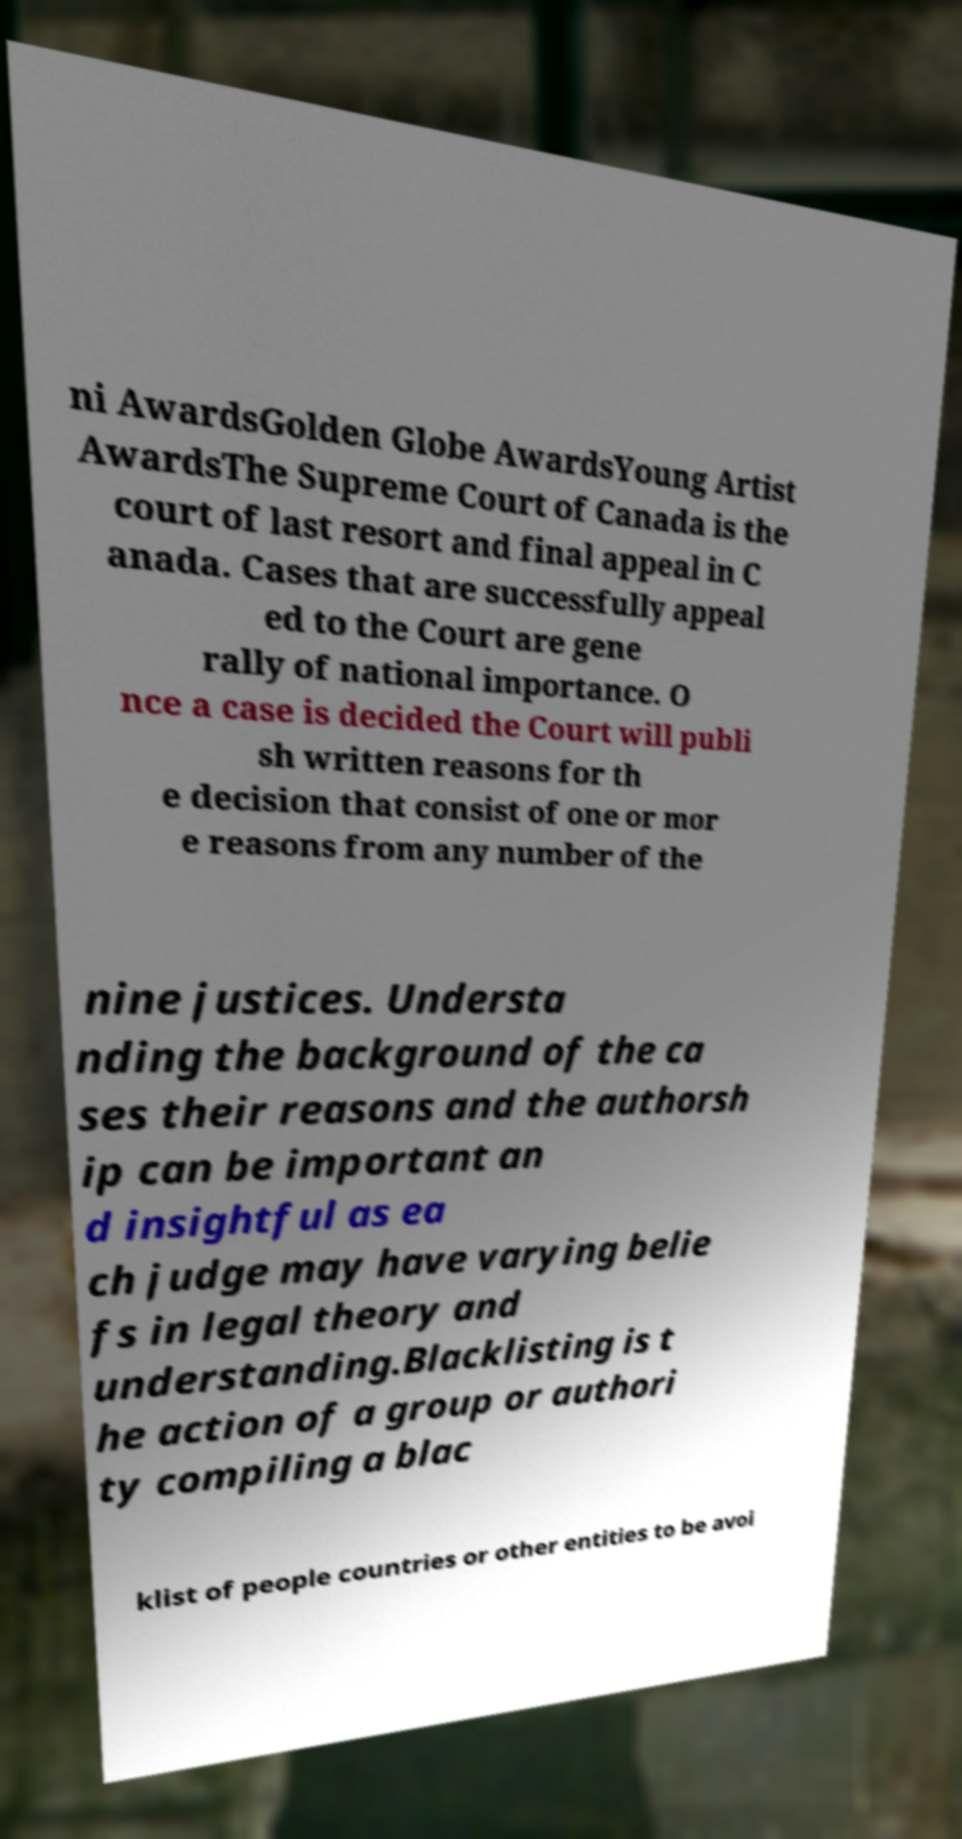What messages or text are displayed in this image? I need them in a readable, typed format. ni AwardsGolden Globe AwardsYoung Artist AwardsThe Supreme Court of Canada is the court of last resort and final appeal in C anada. Cases that are successfully appeal ed to the Court are gene rally of national importance. O nce a case is decided the Court will publi sh written reasons for th e decision that consist of one or mor e reasons from any number of the nine justices. Understa nding the background of the ca ses their reasons and the authorsh ip can be important an d insightful as ea ch judge may have varying belie fs in legal theory and understanding.Blacklisting is t he action of a group or authori ty compiling a blac klist of people countries or other entities to be avoi 